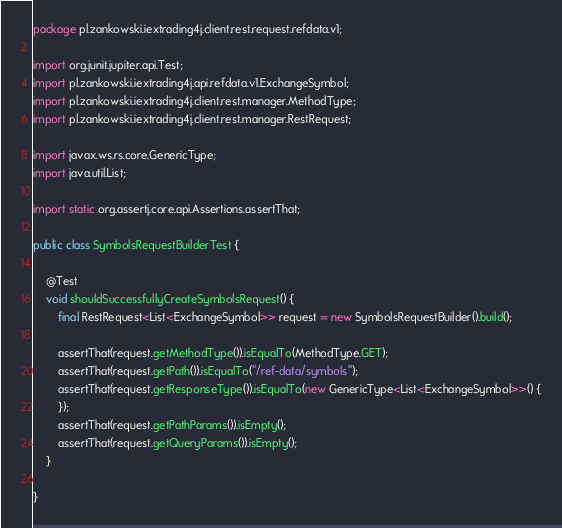Convert code to text. <code><loc_0><loc_0><loc_500><loc_500><_Java_>package pl.zankowski.iextrading4j.client.rest.request.refdata.v1;

import org.junit.jupiter.api.Test;
import pl.zankowski.iextrading4j.api.refdata.v1.ExchangeSymbol;
import pl.zankowski.iextrading4j.client.rest.manager.MethodType;
import pl.zankowski.iextrading4j.client.rest.manager.RestRequest;

import javax.ws.rs.core.GenericType;
import java.util.List;

import static org.assertj.core.api.Assertions.assertThat;

public class SymbolsRequestBuilderTest {

    @Test
    void shouldSuccessfullyCreateSymbolsRequest() {
        final RestRequest<List<ExchangeSymbol>> request = new SymbolsRequestBuilder().build();

        assertThat(request.getMethodType()).isEqualTo(MethodType.GET);
        assertThat(request.getPath()).isEqualTo("/ref-data/symbols");
        assertThat(request.getResponseType()).isEqualTo(new GenericType<List<ExchangeSymbol>>() {
        });
        assertThat(request.getPathParams()).isEmpty();
        assertThat(request.getQueryParams()).isEmpty();
    }

}
</code> 